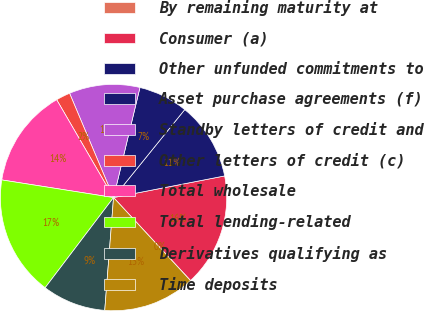<chart> <loc_0><loc_0><loc_500><loc_500><pie_chart><fcel>By remaining maturity at<fcel>Consumer (a)<fcel>Other unfunded commitments to<fcel>Asset purchase agreements (f)<fcel>Standby letters of credit and<fcel>Other letters of credit (c)<fcel>Total wholesale<fcel>Total lending-related<fcel>Derivatives qualifying as<fcel>Time deposits<nl><fcel>0.02%<fcel>16.15%<fcel>11.11%<fcel>7.08%<fcel>10.1%<fcel>2.03%<fcel>14.13%<fcel>17.16%<fcel>9.09%<fcel>13.13%<nl></chart> 